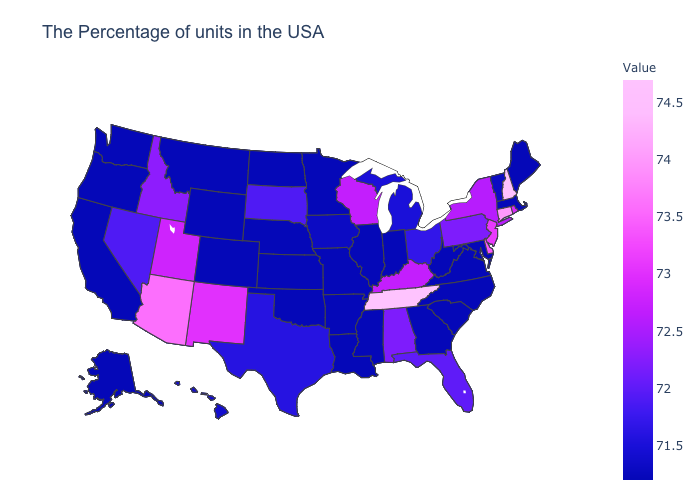Is the legend a continuous bar?
Give a very brief answer. Yes. Does Alabama have a higher value than Kentucky?
Keep it brief. No. Which states have the lowest value in the West?
Be succinct. Wyoming, Colorado, Montana, California, Washington, Oregon, Alaska. 